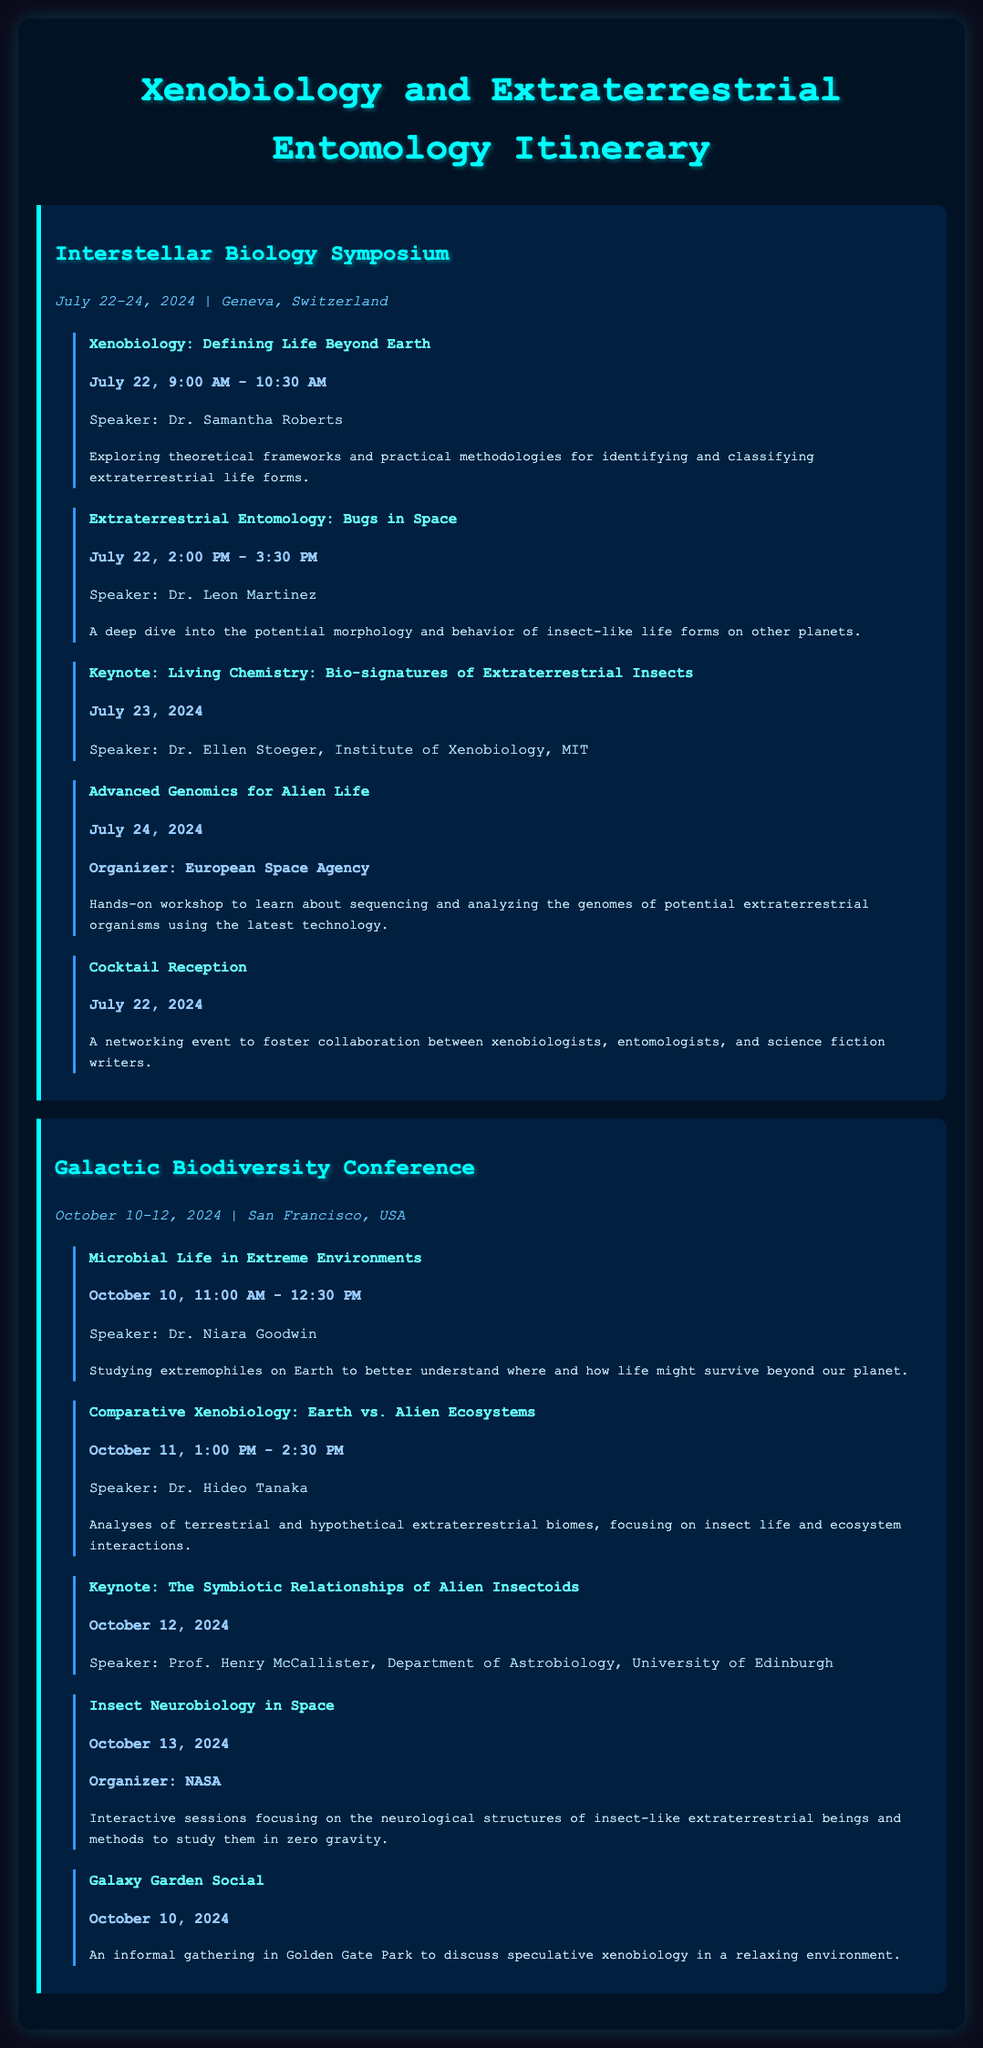What is the date of the Interstellar Biology Symposium? The date for the Interstellar Biology Symposium is mentioned in the document as July 22-24, 2024.
Answer: July 22-24, 2024 Who is the speaker for the session on Extraterrestrial Entomology? The session on Extraterrestrial Entomology features Dr. Leon Martinez as the speaker.
Answer: Dr. Leon Martinez What is the location of the Galactic Biodiversity Conference? The location of the Galactic Biodiversity Conference is specified as San Francisco, USA.
Answer: San Francisco, USA Which organization is hosting the Advanced Genomics for Alien Life workshop? The organizer for the Advanced Genomics for Alien Life workshop is the European Space Agency.
Answer: European Space Agency What is the time for the keynote by Prof. Henry McCallister? The keynote by Prof. Henry McCallister is scheduled for October 12, 2024.
Answer: October 12, 2024 How many sessions are scheduled on October 10, 2024? Two sessions are scheduled on October 10, 2024, one being Microbial Life in Extreme Environments and the other an informal gathering event.
Answer: Two sessions What is the focus of the workshop organized by NASA? The workshop organized by NASA focuses on insect neurobiology in space.
Answer: Insect neurobiology in space What type of event is the Galaxy Garden Social? The Galaxy Garden Social is described as an informal gathering.
Answer: Informal gathering Who is the organizing body of the workshop on Advanced Genomics for Alien Life? The organizing body for the workshop on Advanced Genomics for Alien Life is the European Space Agency.
Answer: European Space Agency 